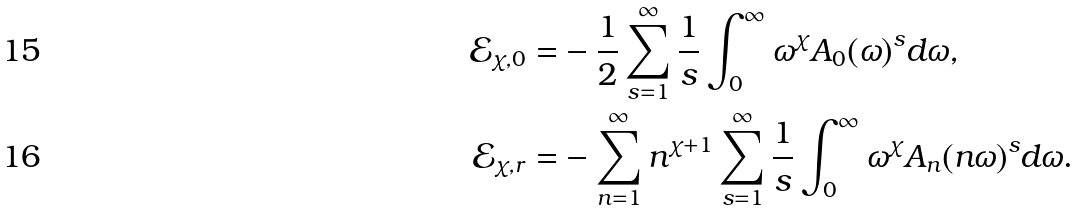Convert formula to latex. <formula><loc_0><loc_0><loc_500><loc_500>\mathcal { E } _ { \chi , 0 } = & - \frac { 1 } { 2 } \sum _ { s = 1 } ^ { \infty } \frac { 1 } { s } \int _ { 0 } ^ { \infty } \omega ^ { \chi } A _ { 0 } ( \omega ) ^ { s } d \omega , \\ \mathcal { E } _ { \chi , r } = & - \sum _ { n = 1 } ^ { \infty } n ^ { \chi + 1 } \sum _ { s = 1 } ^ { \infty } \frac { 1 } { s } \int _ { 0 } ^ { \infty } \omega ^ { \chi } A _ { n } ( n \omega ) ^ { s } d \omega .</formula> 